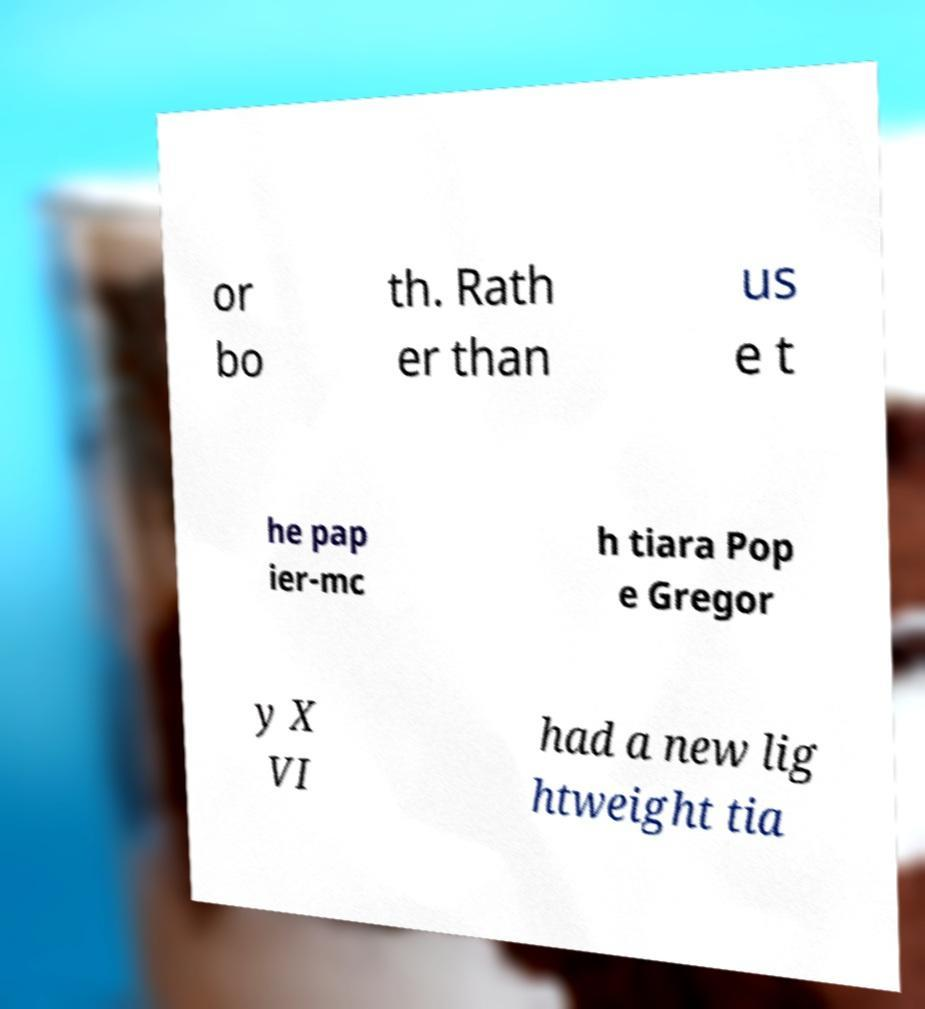I need the written content from this picture converted into text. Can you do that? or bo th. Rath er than us e t he pap ier-mc h tiara Pop e Gregor y X VI had a new lig htweight tia 